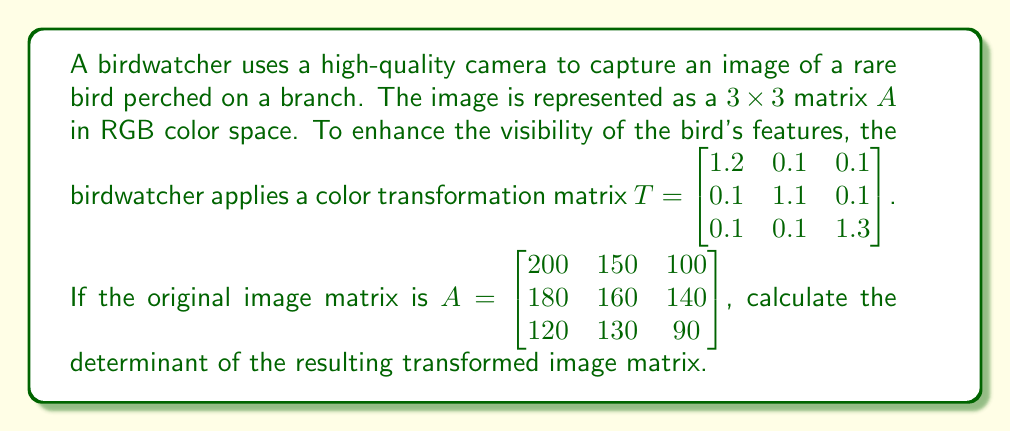Give your solution to this math problem. To solve this problem, we'll follow these steps:

1) The transformation of the image is represented by matrix multiplication: $B = TA$, where $B$ is the transformed image matrix.

2) Let's perform the matrix multiplication:

   $B = \begin{bmatrix} 1.2 & 0.1 & 0.1 \\ 0.1 & 1.1 & 0.1 \\ 0.1 & 0.1 & 1.3 \end{bmatrix} \begin{bmatrix} 200 & 150 & 100 \\ 180 & 160 & 140 \\ 120 & 130 & 90 \end{bmatrix}$

3) Multiplying these matrices:

   $B = \begin{bmatrix}
   (1.2 \times 200 + 0.1 \times 180 + 0.1 \times 120) & (1.2 \times 150 + 0.1 \times 160 + 0.1 \times 130) & (1.2 \times 100 + 0.1 \times 140 + 0.1 \times 90) \\
   (0.1 \times 200 + 1.1 \times 180 + 0.1 \times 120) & (0.1 \times 150 + 1.1 \times 160 + 0.1 \times 130) & (0.1 \times 100 + 1.1 \times 140 + 0.1 \times 90) \\
   (0.1 \times 200 + 0.1 \times 180 + 1.3 \times 120) & (0.1 \times 150 + 0.1 \times 160 + 1.3 \times 130) & (0.1 \times 100 + 0.1 \times 140 + 1.3 \times 90)
   \end{bmatrix}$

4) Calculating each element:

   $B = \begin{bmatrix}
   270 & 204 & 143 \\
   218 & 194 & 165 \\
   194 & 200 & 137
   \end{bmatrix}$

5) Now we need to calculate the determinant of $B$. For a $3 \times 3$ matrix, we can use the following formula:

   $\det(B) = a_{11}(a_{22}a_{33} - a_{23}a_{32}) - a_{12}(a_{21}a_{33} - a_{23}a_{31}) + a_{13}(a_{21}a_{32} - a_{22}a_{31})$

6) Substituting the values:

   $\det(B) = 270((194 \times 137) - (165 \times 200)) - 204((218 \times 137) - (165 \times 194)) + 143((218 \times 200) - (194 \times 194))$

7) Calculating:

   $\det(B) = 270(-5870) - 204(-1358) + 143(4800)$
   
   $= -1,584,900 + 276,932 + 686,400$
   
   $= -621,568$

Therefore, the determinant of the transformed image matrix is -621,568.
Answer: -621,568 